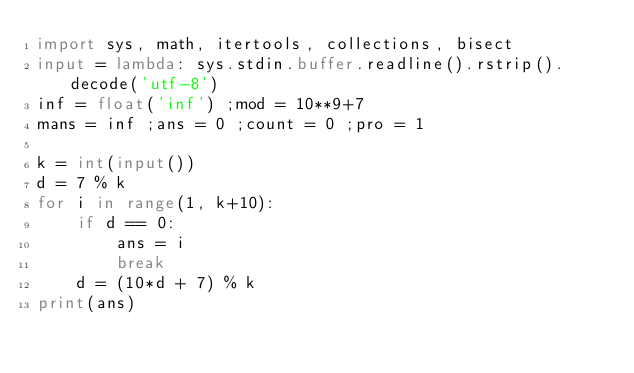<code> <loc_0><loc_0><loc_500><loc_500><_Python_>import sys, math, itertools, collections, bisect 
input = lambda: sys.stdin.buffer.readline().rstrip().decode('utf-8') 
inf = float('inf') ;mod = 10**9+7 
mans = inf ;ans = 0 ;count = 0 ;pro = 1

k = int(input())
d = 7 % k
for i in range(1, k+10):
    if d == 0:
        ans = i
        break
    d = (10*d + 7) % k
print(ans)</code> 